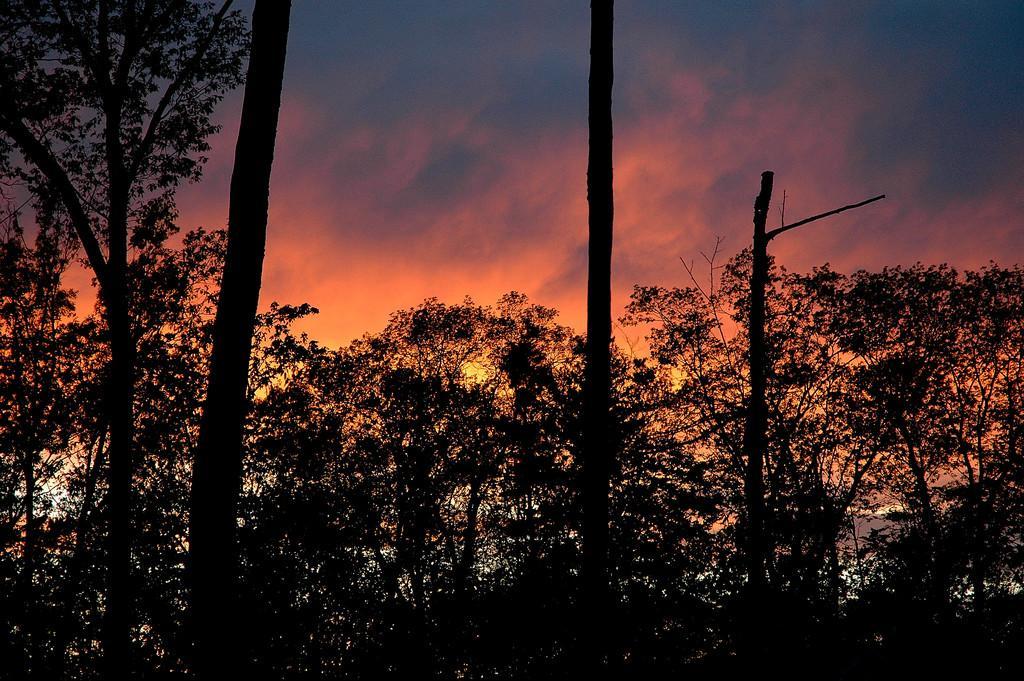Please provide a concise description of this image. In this picture we can see so many trees and we can see sunset. 